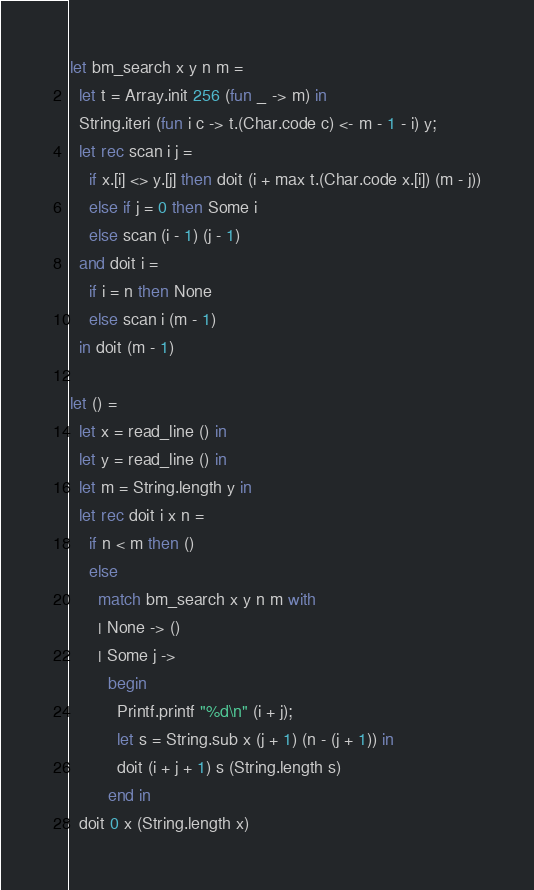<code> <loc_0><loc_0><loc_500><loc_500><_OCaml_>let bm_search x y n m =
  let t = Array.init 256 (fun _ -> m) in
  String.iteri (fun i c -> t.(Char.code c) <- m - 1 - i) y;
  let rec scan i j =
    if x.[i] <> y.[j] then doit (i + max t.(Char.code x.[i]) (m - j))
    else if j = 0 then Some i
    else scan (i - 1) (j - 1)
  and doit i =
    if i = n then None
    else scan i (m - 1)
  in doit (m - 1)

let () =
  let x = read_line () in
  let y = read_line () in
  let m = String.length y in
  let rec doit i x n =
    if n < m then ()
    else
      match bm_search x y n m with
      | None -> ()
      | Some j ->
        begin
          Printf.printf "%d\n" (i + j);
          let s = String.sub x (j + 1) (n - (j + 1)) in
          doit (i + j + 1) s (String.length s)
        end in
  doit 0 x (String.length x)</code> 